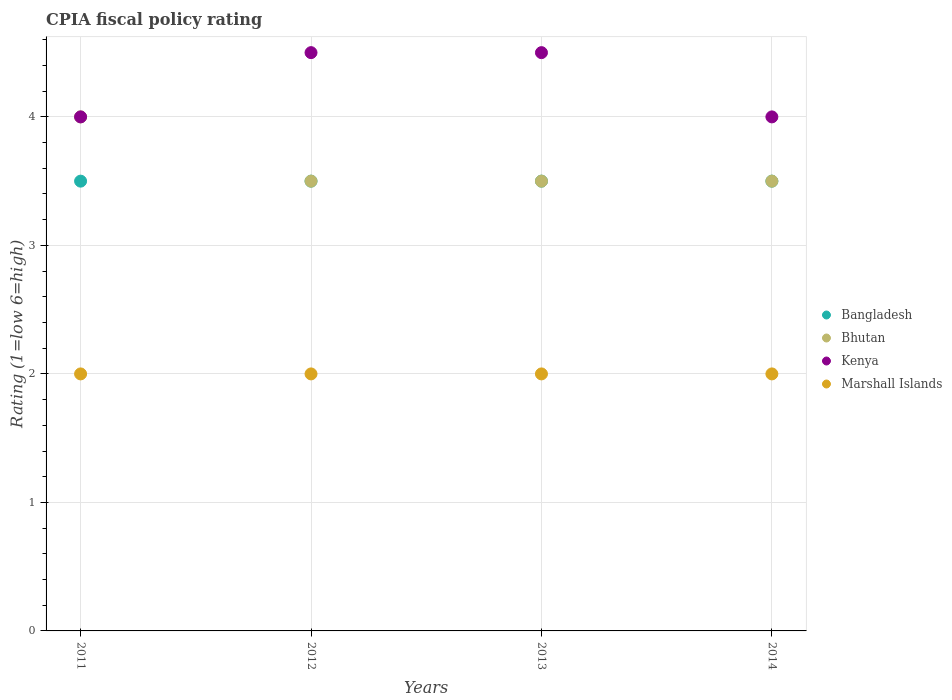Is the number of dotlines equal to the number of legend labels?
Your answer should be compact. Yes. In which year was the CPIA rating in Kenya maximum?
Your answer should be compact. 2012. In which year was the CPIA rating in Bangladesh minimum?
Offer a terse response. 2011. What is the difference between the CPIA rating in Bangladesh in 2011 and that in 2013?
Offer a terse response. 0. What is the average CPIA rating in Kenya per year?
Keep it short and to the point. 4.25. In how many years, is the CPIA rating in Kenya greater than 1.4?
Your answer should be compact. 4. Is it the case that in every year, the sum of the CPIA rating in Bangladesh and CPIA rating in Bhutan  is greater than the sum of CPIA rating in Marshall Islands and CPIA rating in Kenya?
Provide a short and direct response. Yes. Is it the case that in every year, the sum of the CPIA rating in Bhutan and CPIA rating in Kenya  is greater than the CPIA rating in Bangladesh?
Your answer should be very brief. Yes. Is the CPIA rating in Marshall Islands strictly less than the CPIA rating in Bangladesh over the years?
Your answer should be compact. Yes. How many years are there in the graph?
Offer a terse response. 4. Does the graph contain any zero values?
Make the answer very short. No. Does the graph contain grids?
Give a very brief answer. Yes. How are the legend labels stacked?
Make the answer very short. Vertical. What is the title of the graph?
Offer a terse response. CPIA fiscal policy rating. Does "Guinea-Bissau" appear as one of the legend labels in the graph?
Make the answer very short. No. What is the label or title of the Y-axis?
Your response must be concise. Rating (1=low 6=high). What is the Rating (1=low 6=high) in Bhutan in 2011?
Ensure brevity in your answer.  4. What is the Rating (1=low 6=high) in Bangladesh in 2012?
Offer a very short reply. 3.5. What is the Rating (1=low 6=high) of Kenya in 2012?
Offer a terse response. 4.5. What is the Rating (1=low 6=high) of Marshall Islands in 2012?
Ensure brevity in your answer.  2. What is the Rating (1=low 6=high) in Bangladesh in 2013?
Provide a short and direct response. 3.5. What is the Rating (1=low 6=high) in Bangladesh in 2014?
Offer a terse response. 3.5. What is the Rating (1=low 6=high) in Bhutan in 2014?
Provide a succinct answer. 3.5. What is the Rating (1=low 6=high) of Marshall Islands in 2014?
Provide a succinct answer. 2. Across all years, what is the maximum Rating (1=low 6=high) of Bangladesh?
Ensure brevity in your answer.  3.5. Across all years, what is the maximum Rating (1=low 6=high) in Kenya?
Provide a succinct answer. 4.5. Across all years, what is the minimum Rating (1=low 6=high) in Bangladesh?
Your response must be concise. 3.5. Across all years, what is the minimum Rating (1=low 6=high) of Bhutan?
Provide a succinct answer. 3.5. What is the total Rating (1=low 6=high) in Kenya in the graph?
Make the answer very short. 17. What is the total Rating (1=low 6=high) of Marshall Islands in the graph?
Make the answer very short. 8. What is the difference between the Rating (1=low 6=high) of Bhutan in 2011 and that in 2012?
Provide a succinct answer. 0.5. What is the difference between the Rating (1=low 6=high) in Kenya in 2011 and that in 2012?
Ensure brevity in your answer.  -0.5. What is the difference between the Rating (1=low 6=high) of Bangladesh in 2011 and that in 2013?
Your answer should be very brief. 0. What is the difference between the Rating (1=low 6=high) in Kenya in 2011 and that in 2013?
Keep it short and to the point. -0.5. What is the difference between the Rating (1=low 6=high) in Marshall Islands in 2011 and that in 2013?
Give a very brief answer. 0. What is the difference between the Rating (1=low 6=high) of Bangladesh in 2011 and that in 2014?
Your answer should be very brief. 0. What is the difference between the Rating (1=low 6=high) of Marshall Islands in 2011 and that in 2014?
Your answer should be compact. 0. What is the difference between the Rating (1=low 6=high) in Bhutan in 2012 and that in 2013?
Provide a short and direct response. 0. What is the difference between the Rating (1=low 6=high) of Kenya in 2012 and that in 2013?
Offer a very short reply. 0. What is the difference between the Rating (1=low 6=high) in Kenya in 2012 and that in 2014?
Your answer should be very brief. 0.5. What is the difference between the Rating (1=low 6=high) in Kenya in 2013 and that in 2014?
Your answer should be compact. 0.5. What is the difference between the Rating (1=low 6=high) in Bangladesh in 2011 and the Rating (1=low 6=high) in Bhutan in 2012?
Offer a terse response. 0. What is the difference between the Rating (1=low 6=high) of Bangladesh in 2011 and the Rating (1=low 6=high) of Kenya in 2012?
Offer a very short reply. -1. What is the difference between the Rating (1=low 6=high) in Bangladesh in 2011 and the Rating (1=low 6=high) in Marshall Islands in 2012?
Keep it short and to the point. 1.5. What is the difference between the Rating (1=low 6=high) in Bhutan in 2011 and the Rating (1=low 6=high) in Marshall Islands in 2012?
Your answer should be compact. 2. What is the difference between the Rating (1=low 6=high) in Bhutan in 2011 and the Rating (1=low 6=high) in Kenya in 2013?
Offer a terse response. -0.5. What is the difference between the Rating (1=low 6=high) in Bangladesh in 2011 and the Rating (1=low 6=high) in Kenya in 2014?
Provide a succinct answer. -0.5. What is the difference between the Rating (1=low 6=high) in Bangladesh in 2011 and the Rating (1=low 6=high) in Marshall Islands in 2014?
Offer a very short reply. 1.5. What is the difference between the Rating (1=low 6=high) in Bhutan in 2011 and the Rating (1=low 6=high) in Kenya in 2014?
Your answer should be very brief. 0. What is the difference between the Rating (1=low 6=high) of Bhutan in 2011 and the Rating (1=low 6=high) of Marshall Islands in 2014?
Provide a succinct answer. 2. What is the difference between the Rating (1=low 6=high) in Kenya in 2011 and the Rating (1=low 6=high) in Marshall Islands in 2014?
Make the answer very short. 2. What is the difference between the Rating (1=low 6=high) of Bangladesh in 2012 and the Rating (1=low 6=high) of Bhutan in 2013?
Make the answer very short. 0. What is the difference between the Rating (1=low 6=high) of Bangladesh in 2012 and the Rating (1=low 6=high) of Kenya in 2013?
Offer a terse response. -1. What is the difference between the Rating (1=low 6=high) of Bangladesh in 2012 and the Rating (1=low 6=high) of Marshall Islands in 2013?
Make the answer very short. 1.5. What is the difference between the Rating (1=low 6=high) of Bhutan in 2012 and the Rating (1=low 6=high) of Kenya in 2013?
Provide a short and direct response. -1. What is the difference between the Rating (1=low 6=high) in Kenya in 2012 and the Rating (1=low 6=high) in Marshall Islands in 2013?
Your response must be concise. 2.5. What is the difference between the Rating (1=low 6=high) in Bangladesh in 2012 and the Rating (1=low 6=high) in Bhutan in 2014?
Offer a very short reply. 0. What is the difference between the Rating (1=low 6=high) in Bhutan in 2012 and the Rating (1=low 6=high) in Marshall Islands in 2014?
Ensure brevity in your answer.  1.5. What is the difference between the Rating (1=low 6=high) of Bangladesh in 2013 and the Rating (1=low 6=high) of Bhutan in 2014?
Ensure brevity in your answer.  0. What is the difference between the Rating (1=low 6=high) in Bhutan in 2013 and the Rating (1=low 6=high) in Kenya in 2014?
Your response must be concise. -0.5. What is the difference between the Rating (1=low 6=high) of Bhutan in 2013 and the Rating (1=low 6=high) of Marshall Islands in 2014?
Your answer should be very brief. 1.5. What is the difference between the Rating (1=low 6=high) of Kenya in 2013 and the Rating (1=low 6=high) of Marshall Islands in 2014?
Make the answer very short. 2.5. What is the average Rating (1=low 6=high) of Bhutan per year?
Keep it short and to the point. 3.62. What is the average Rating (1=low 6=high) in Kenya per year?
Your answer should be very brief. 4.25. In the year 2011, what is the difference between the Rating (1=low 6=high) in Bangladesh and Rating (1=low 6=high) in Kenya?
Offer a terse response. -0.5. In the year 2011, what is the difference between the Rating (1=low 6=high) of Bangladesh and Rating (1=low 6=high) of Marshall Islands?
Keep it short and to the point. 1.5. In the year 2011, what is the difference between the Rating (1=low 6=high) of Kenya and Rating (1=low 6=high) of Marshall Islands?
Ensure brevity in your answer.  2. In the year 2012, what is the difference between the Rating (1=low 6=high) in Kenya and Rating (1=low 6=high) in Marshall Islands?
Make the answer very short. 2.5. In the year 2013, what is the difference between the Rating (1=low 6=high) of Bangladesh and Rating (1=low 6=high) of Marshall Islands?
Make the answer very short. 1.5. In the year 2013, what is the difference between the Rating (1=low 6=high) in Bhutan and Rating (1=low 6=high) in Kenya?
Ensure brevity in your answer.  -1. In the year 2014, what is the difference between the Rating (1=low 6=high) in Bangladesh and Rating (1=low 6=high) in Kenya?
Your answer should be compact. -0.5. In the year 2014, what is the difference between the Rating (1=low 6=high) in Bangladesh and Rating (1=low 6=high) in Marshall Islands?
Your response must be concise. 1.5. What is the ratio of the Rating (1=low 6=high) of Bangladesh in 2011 to that in 2012?
Give a very brief answer. 1. What is the ratio of the Rating (1=low 6=high) in Bhutan in 2011 to that in 2012?
Your answer should be compact. 1.14. What is the ratio of the Rating (1=low 6=high) in Kenya in 2011 to that in 2012?
Give a very brief answer. 0.89. What is the ratio of the Rating (1=low 6=high) in Marshall Islands in 2011 to that in 2012?
Offer a terse response. 1. What is the ratio of the Rating (1=low 6=high) in Bangladesh in 2011 to that in 2013?
Ensure brevity in your answer.  1. What is the ratio of the Rating (1=low 6=high) in Marshall Islands in 2011 to that in 2013?
Give a very brief answer. 1. What is the ratio of the Rating (1=low 6=high) of Kenya in 2011 to that in 2014?
Your answer should be very brief. 1. What is the ratio of the Rating (1=low 6=high) in Marshall Islands in 2011 to that in 2014?
Keep it short and to the point. 1. What is the ratio of the Rating (1=low 6=high) of Kenya in 2012 to that in 2013?
Provide a succinct answer. 1. What is the ratio of the Rating (1=low 6=high) of Bhutan in 2012 to that in 2014?
Keep it short and to the point. 1. What is the ratio of the Rating (1=low 6=high) in Kenya in 2012 to that in 2014?
Offer a very short reply. 1.12. What is the ratio of the Rating (1=low 6=high) in Marshall Islands in 2013 to that in 2014?
Provide a short and direct response. 1. What is the difference between the highest and the second highest Rating (1=low 6=high) in Kenya?
Your answer should be very brief. 0. What is the difference between the highest and the second highest Rating (1=low 6=high) in Marshall Islands?
Your response must be concise. 0. What is the difference between the highest and the lowest Rating (1=low 6=high) in Bangladesh?
Make the answer very short. 0. 